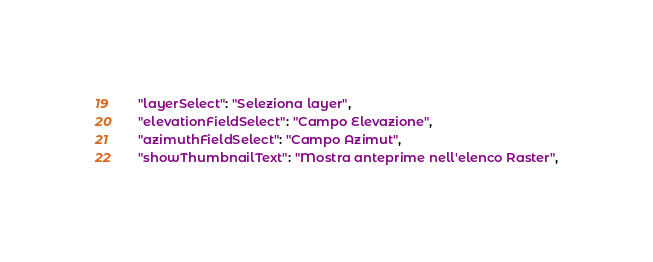Convert code to text. <code><loc_0><loc_0><loc_500><loc_500><_JavaScript_>  "layerSelect": "Seleziona layer",
  "elevationFieldSelect": "Campo Elevazione",
  "azimuthFieldSelect": "Campo Azimut",
  "showThumbnailText": "Mostra anteprime nell'elenco Raster",</code> 